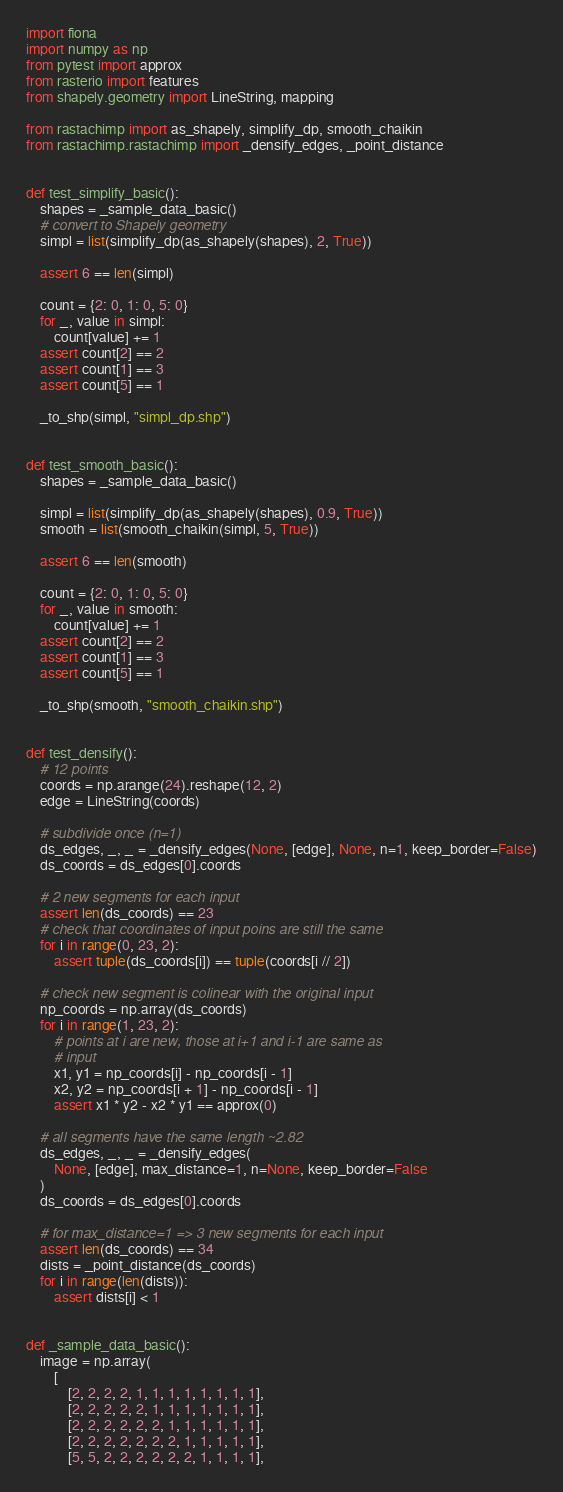<code> <loc_0><loc_0><loc_500><loc_500><_Python_>import fiona
import numpy as np
from pytest import approx
from rasterio import features
from shapely.geometry import LineString, mapping

from rastachimp import as_shapely, simplify_dp, smooth_chaikin
from rastachimp.rastachimp import _densify_edges, _point_distance


def test_simplify_basic():
    shapes = _sample_data_basic()
    # convert to Shapely geometry
    simpl = list(simplify_dp(as_shapely(shapes), 2, True))

    assert 6 == len(simpl)

    count = {2: 0, 1: 0, 5: 0}
    for _, value in simpl:
        count[value] += 1
    assert count[2] == 2
    assert count[1] == 3
    assert count[5] == 1

    _to_shp(simpl, "simpl_dp.shp")


def test_smooth_basic():
    shapes = _sample_data_basic()

    simpl = list(simplify_dp(as_shapely(shapes), 0.9, True))
    smooth = list(smooth_chaikin(simpl, 5, True))

    assert 6 == len(smooth)

    count = {2: 0, 1: 0, 5: 0}
    for _, value in smooth:
        count[value] += 1
    assert count[2] == 2
    assert count[1] == 3
    assert count[5] == 1

    _to_shp(smooth, "smooth_chaikin.shp")


def test_densify():
    # 12 points
    coords = np.arange(24).reshape(12, 2)
    edge = LineString(coords)

    # subdivide once (n=1)
    ds_edges, _, _ = _densify_edges(None, [edge], None, n=1, keep_border=False)
    ds_coords = ds_edges[0].coords

    # 2 new segments for each input
    assert len(ds_coords) == 23
    # check that coordinates of input poins are still the same
    for i in range(0, 23, 2):
        assert tuple(ds_coords[i]) == tuple(coords[i // 2])

    # check new segment is colinear with the original input
    np_coords = np.array(ds_coords)
    for i in range(1, 23, 2):
        # points at i are new, those at i+1 and i-1 are same as
        # input
        x1, y1 = np_coords[i] - np_coords[i - 1]
        x2, y2 = np_coords[i + 1] - np_coords[i - 1]
        assert x1 * y2 - x2 * y1 == approx(0)

    # all segments have the same length ~2.82
    ds_edges, _, _ = _densify_edges(
        None, [edge], max_distance=1, n=None, keep_border=False
    )
    ds_coords = ds_edges[0].coords

    # for max_distance=1 => 3 new segments for each input
    assert len(ds_coords) == 34
    dists = _point_distance(ds_coords)
    for i in range(len(dists)):
        assert dists[i] < 1


def _sample_data_basic():
    image = np.array(
        [
            [2, 2, 2, 2, 1, 1, 1, 1, 1, 1, 1, 1],
            [2, 2, 2, 2, 2, 1, 1, 1, 1, 1, 1, 1],
            [2, 2, 2, 2, 2, 2, 1, 1, 1, 1, 1, 1],
            [2, 2, 2, 2, 2, 2, 2, 1, 1, 1, 1, 1],
            [5, 5, 2, 2, 2, 2, 2, 2, 1, 1, 1, 1],</code> 